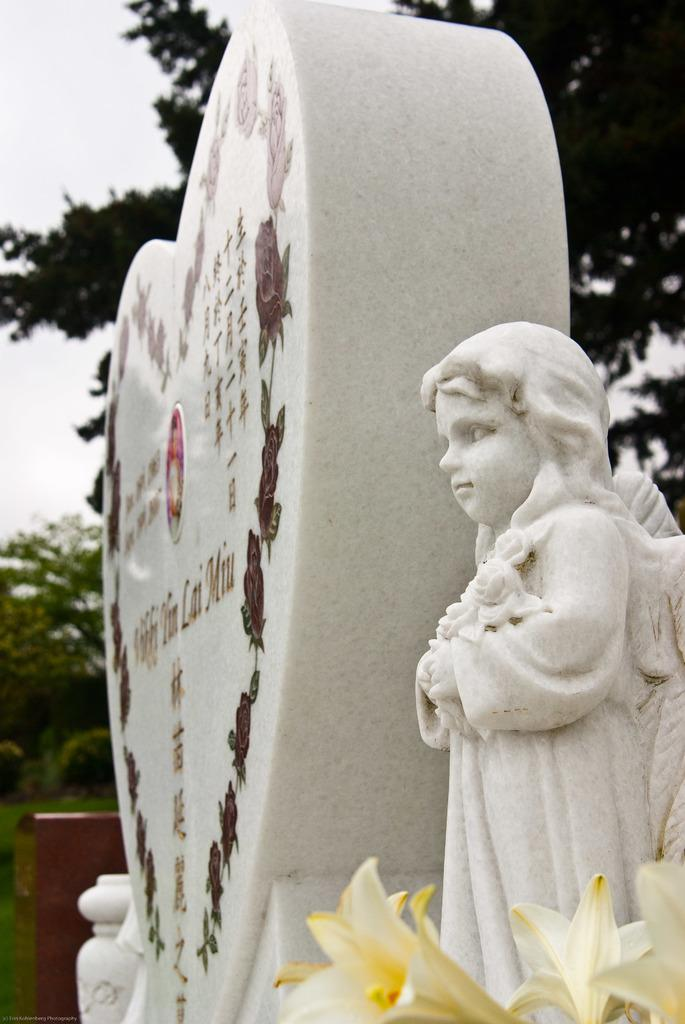What type of plants can be seen in the image? There are flowers in the image. What type of artwork is present in the image? There are sculptures in the image. What can be seen in the background of the image? There are trees and the sky visible in the background of the image. What type of kite can be seen flying in the image? There is no kite present in the image; it features flowers, sculptures, trees, and the sky. 